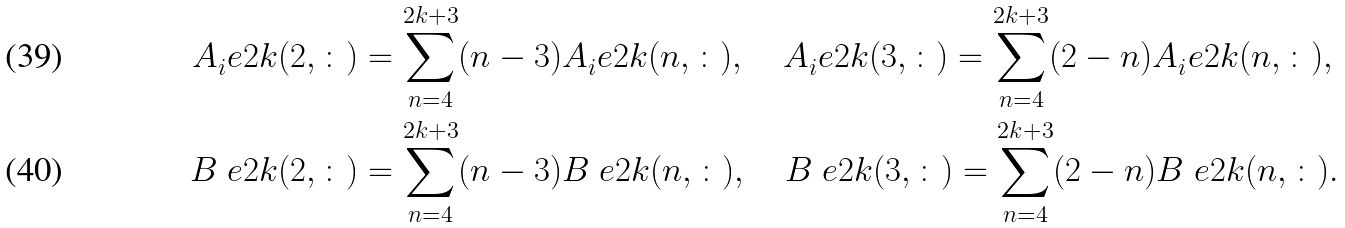<formula> <loc_0><loc_0><loc_500><loc_500>A _ { i } ^ { \ } e { 2 k } ( 2 , \colon ) & = \sum _ { n = 4 } ^ { 2 k + 3 } ( n - 3 ) A _ { i } ^ { \ } e { 2 k } ( n , \colon ) , \quad A _ { i } ^ { \ } e { 2 k } ( 3 , \colon ) = \sum _ { n = 4 } ^ { 2 k + 3 } ( 2 - n ) A _ { i } ^ { \ } e { 2 k } ( n , \colon ) , \\ B ^ { \ } e { 2 k } ( 2 , \colon ) & = \sum _ { n = 4 } ^ { 2 k + 3 } ( n - 3 ) B ^ { \ } e { 2 k } ( n , \colon ) , \quad B ^ { \ } e { 2 k } ( 3 , \colon ) = \sum _ { n = 4 } ^ { 2 k + 3 } ( 2 - n ) B ^ { \ } e { 2 k } ( n , \colon ) .</formula> 